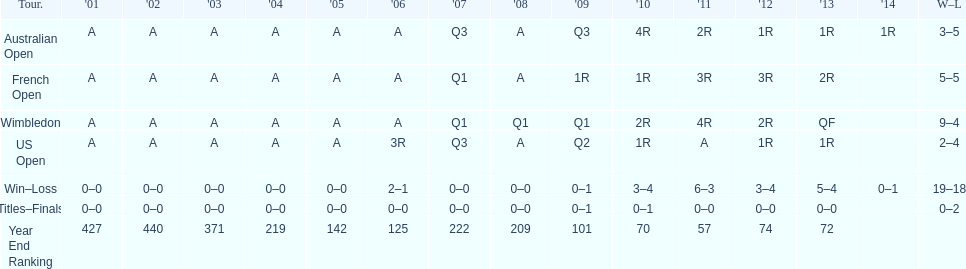What was this players average ranking between 2001 and 2006? 287. 